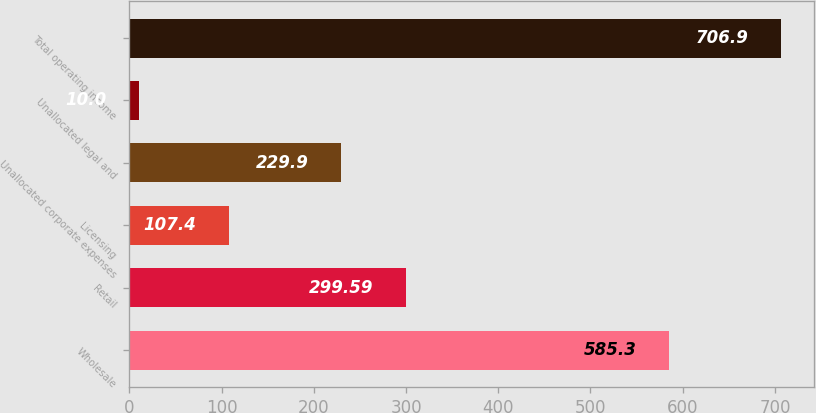Convert chart. <chart><loc_0><loc_0><loc_500><loc_500><bar_chart><fcel>Wholesale<fcel>Retail<fcel>Licensing<fcel>Unallocated corporate expenses<fcel>Unallocated legal and<fcel>Total operating income<nl><fcel>585.3<fcel>299.59<fcel>107.4<fcel>229.9<fcel>10<fcel>706.9<nl></chart> 